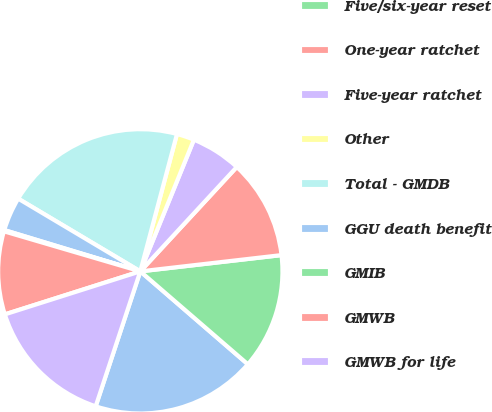Convert chart to OTSL. <chart><loc_0><loc_0><loc_500><loc_500><pie_chart><fcel>Return of premium<fcel>Five/six-year reset<fcel>One-year ratchet<fcel>Five-year ratchet<fcel>Other<fcel>Total - GMDB<fcel>GGU death benefit<fcel>GMIB<fcel>GMWB<fcel>GMWB for life<nl><fcel>18.74%<fcel>13.16%<fcel>11.3%<fcel>5.72%<fcel>2.0%<fcel>20.6%<fcel>3.86%<fcel>0.14%<fcel>9.44%<fcel>15.02%<nl></chart> 